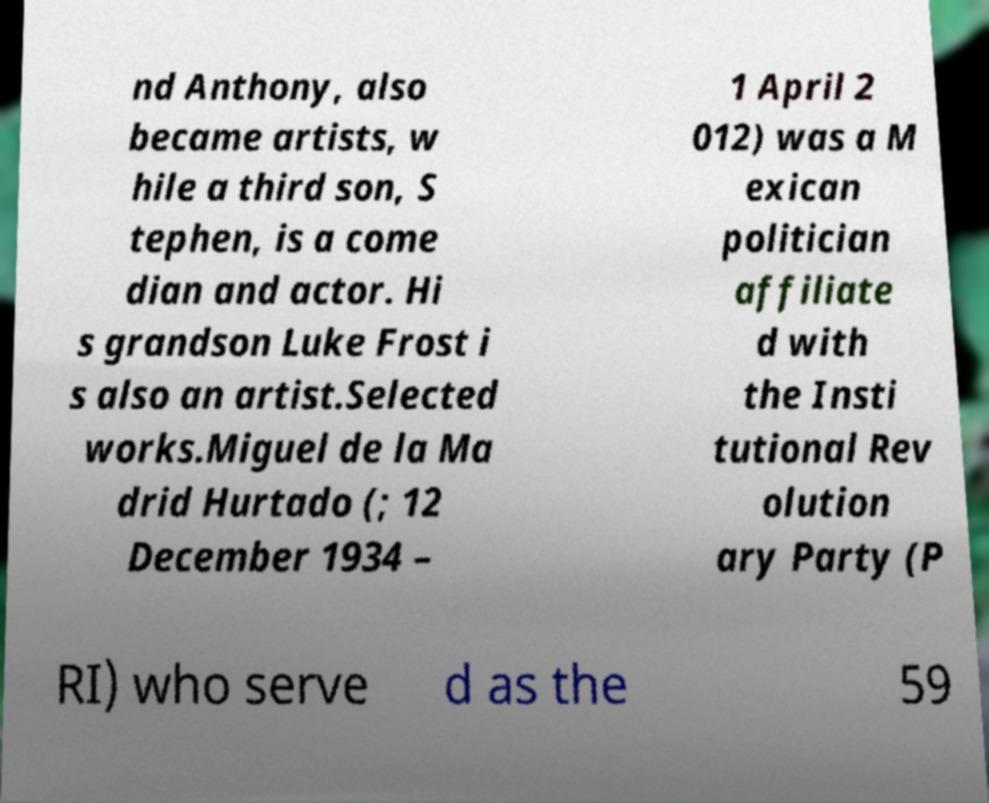Can you accurately transcribe the text from the provided image for me? nd Anthony, also became artists, w hile a third son, S tephen, is a come dian and actor. Hi s grandson Luke Frost i s also an artist.Selected works.Miguel de la Ma drid Hurtado (; 12 December 1934 – 1 April 2 012) was a M exican politician affiliate d with the Insti tutional Rev olution ary Party (P RI) who serve d as the 59 